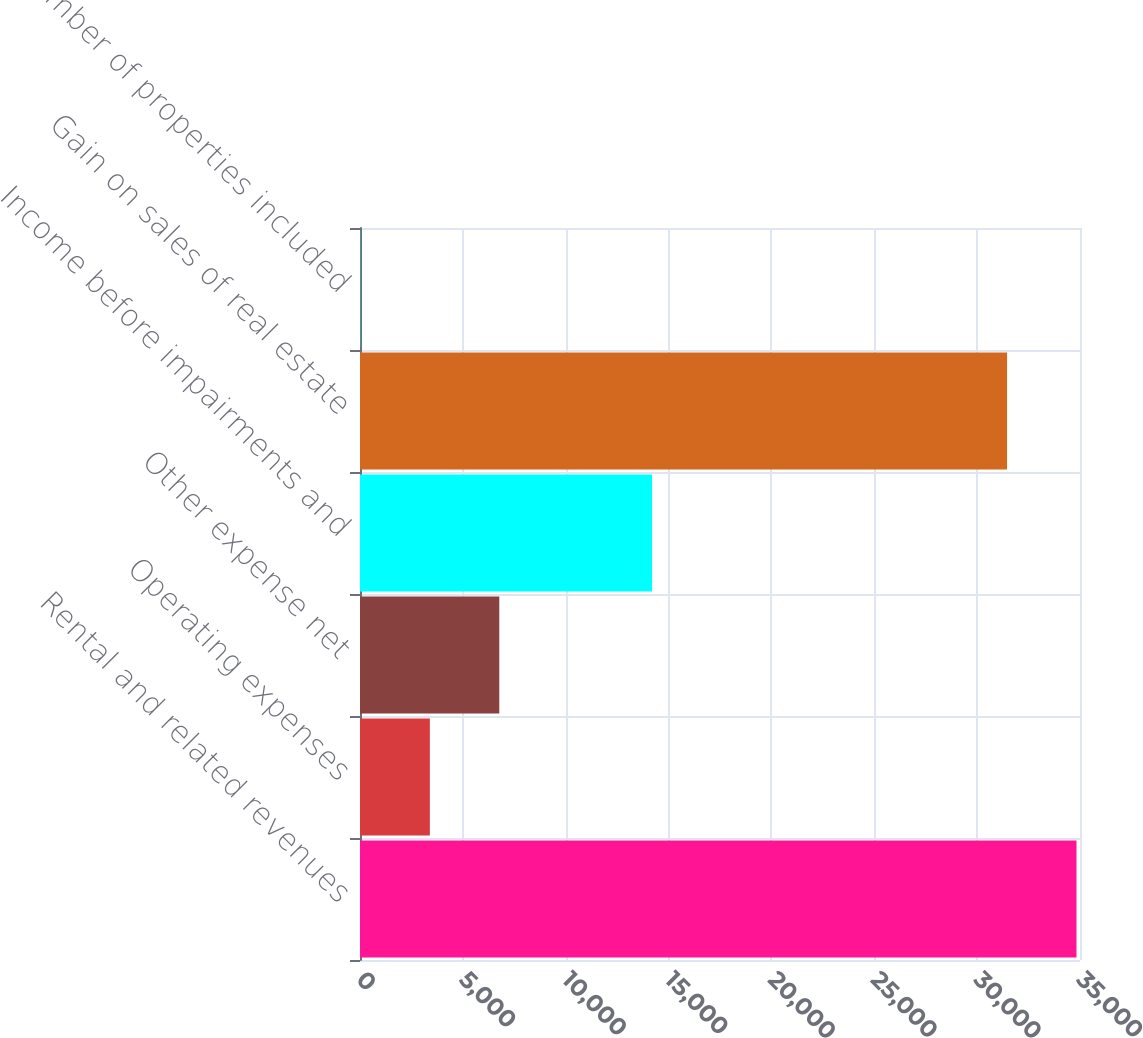<chart> <loc_0><loc_0><loc_500><loc_500><bar_chart><fcel>Rental and related revenues<fcel>Operating expenses<fcel>Other expense net<fcel>Income before impairments and<fcel>Gain on sales of real estate<fcel>Number of properties included<nl><fcel>34829.7<fcel>3395.7<fcel>6771.4<fcel>14198<fcel>31454<fcel>20<nl></chart> 